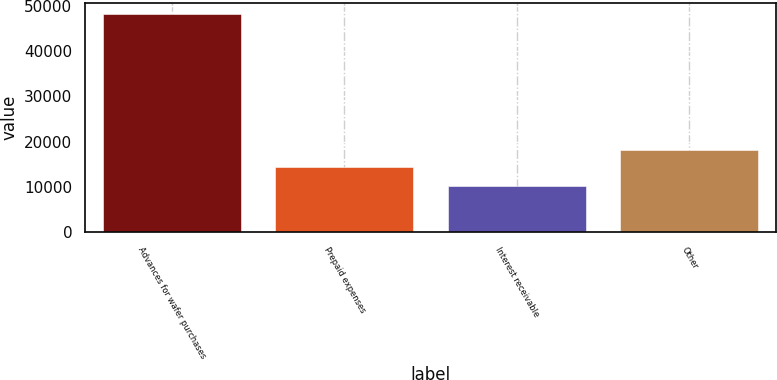<chart> <loc_0><loc_0><loc_500><loc_500><bar_chart><fcel>Advances for wafer purchases<fcel>Prepaid expenses<fcel>Interest receivable<fcel>Other<nl><fcel>48281<fcel>14484<fcel>10229<fcel>18289.2<nl></chart> 